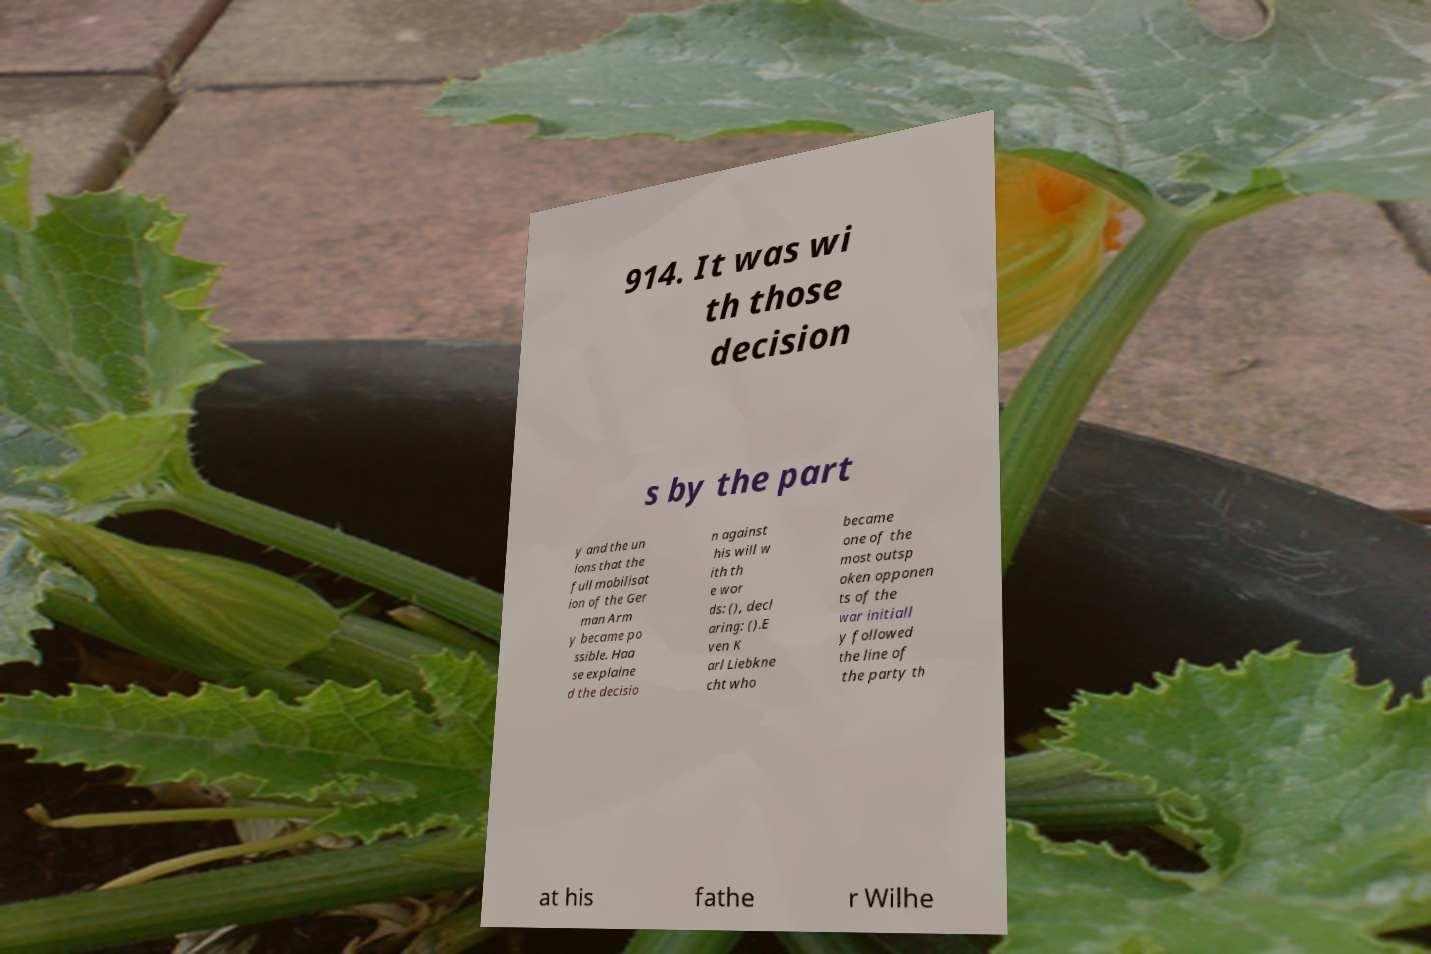For documentation purposes, I need the text within this image transcribed. Could you provide that? 914. It was wi th those decision s by the part y and the un ions that the full mobilisat ion of the Ger man Arm y became po ssible. Haa se explaine d the decisio n against his will w ith th e wor ds: (), decl aring: ().E ven K arl Liebkne cht who became one of the most outsp oken opponen ts of the war initiall y followed the line of the party th at his fathe r Wilhe 